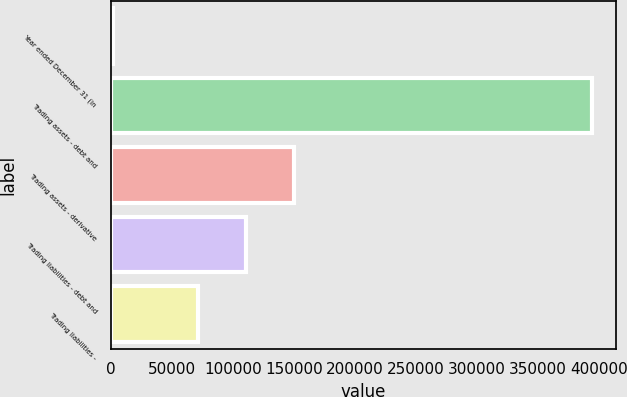<chart> <loc_0><loc_0><loc_500><loc_500><bar_chart><fcel>Year ended December 31 (in<fcel>Trading assets - debt and<fcel>Trading assets - derivative<fcel>Trading liabilities - debt and<fcel>Trading liabilities -<nl><fcel>2011<fcel>393890<fcel>149915<fcel>110727<fcel>71539<nl></chart> 